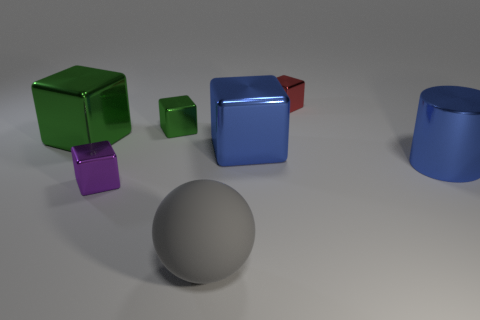Subtract all big blue cubes. How many cubes are left? 4 Subtract all red cylinders. How many green cubes are left? 2 Add 2 green cubes. How many objects exist? 9 Subtract all purple cubes. How many cubes are left? 4 Subtract all balls. How many objects are left? 6 Subtract 2 blocks. How many blocks are left? 3 Subtract all purple cylinders. Subtract all red cubes. How many cylinders are left? 1 Subtract all metallic cylinders. Subtract all tiny gray shiny cubes. How many objects are left? 6 Add 2 large gray objects. How many large gray objects are left? 3 Add 2 small green blocks. How many small green blocks exist? 3 